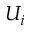Convert formula to latex. <formula><loc_0><loc_0><loc_500><loc_500>U _ { i }</formula> 